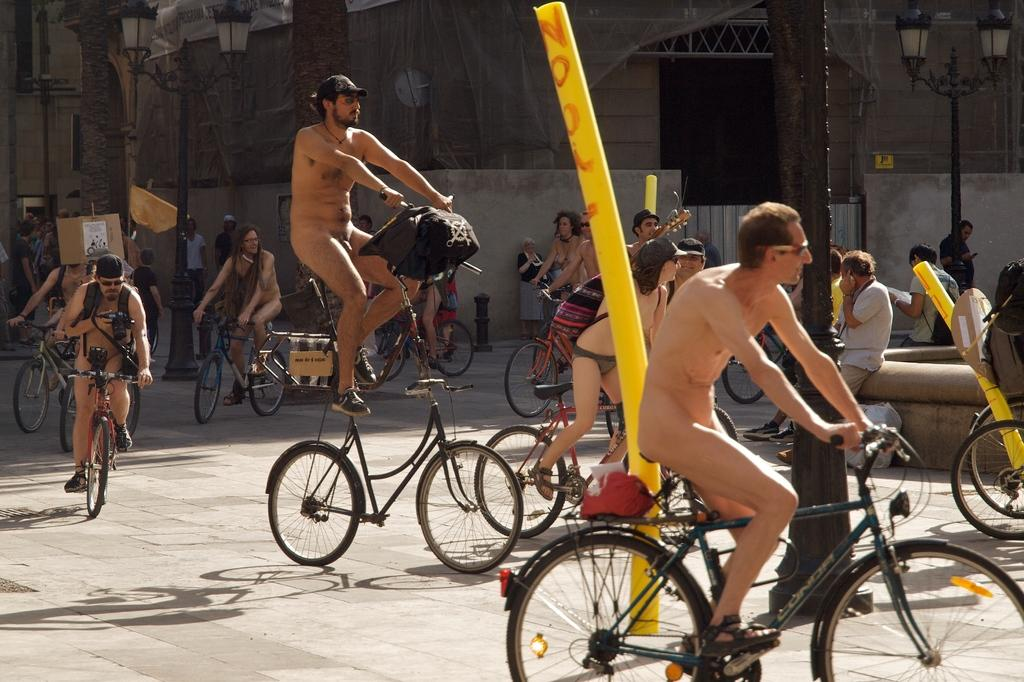What are the people in the image doing? The people in the image are riding bicycles. Where are the people riding their bicycles? The people are on the road. What can be seen in the background of the image? There are street lights and at least one building in the background of the image. What type of receipt can be seen in the image? There is no receipt present in the image. How does the concept of loss relate to the image? The concept of loss does not have a direct connection to the image, as it features people riding bicycles on the road. 